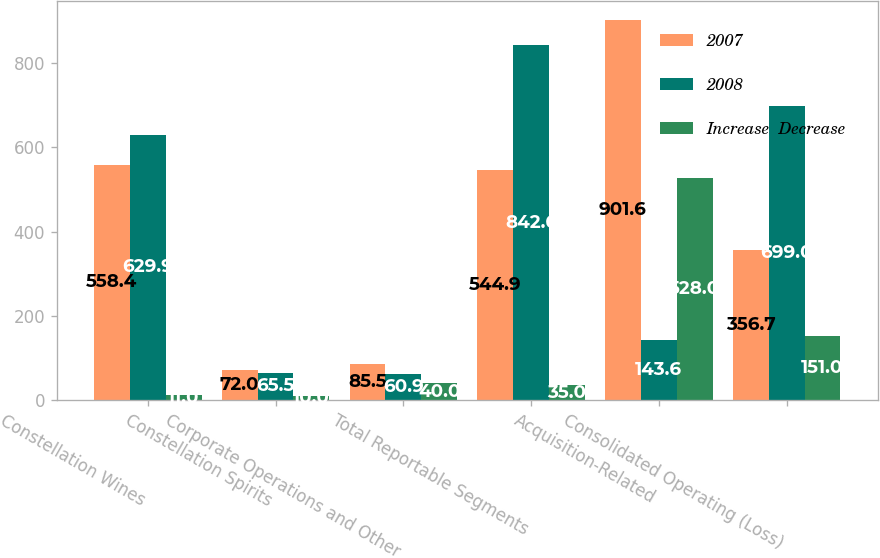Convert chart to OTSL. <chart><loc_0><loc_0><loc_500><loc_500><stacked_bar_chart><ecel><fcel>Constellation Wines<fcel>Constellation Spirits<fcel>Corporate Operations and Other<fcel>Total Reportable Segments<fcel>Acquisition-Related<fcel>Consolidated Operating (Loss)<nl><fcel>2007<fcel>558.4<fcel>72<fcel>85.5<fcel>544.9<fcel>901.6<fcel>356.7<nl><fcel>2008<fcel>629.9<fcel>65.5<fcel>60.9<fcel>842.6<fcel>143.6<fcel>699<nl><fcel>Increase  Decrease<fcel>11<fcel>10<fcel>40<fcel>35<fcel>528<fcel>151<nl></chart> 